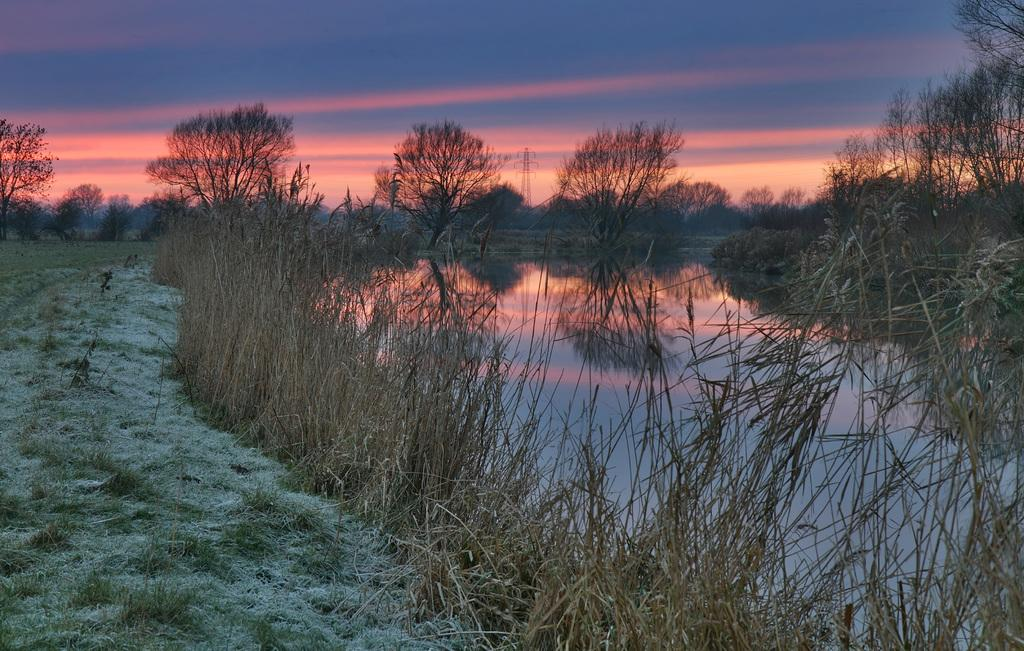What is the primary element in the image? There is water in the image. What type of vegetation can be seen near the water? There is grass visible near the water. How many trees are present in the image? There are many trees in the image. What can be seen in the background of the image? There is a tower, clouds, and the sky visible in the background of the image. Can you see anyone wearing a mask in the image? There is no mention of any people or masks in the image, so it cannot be determined if anyone is wearing a mask. 